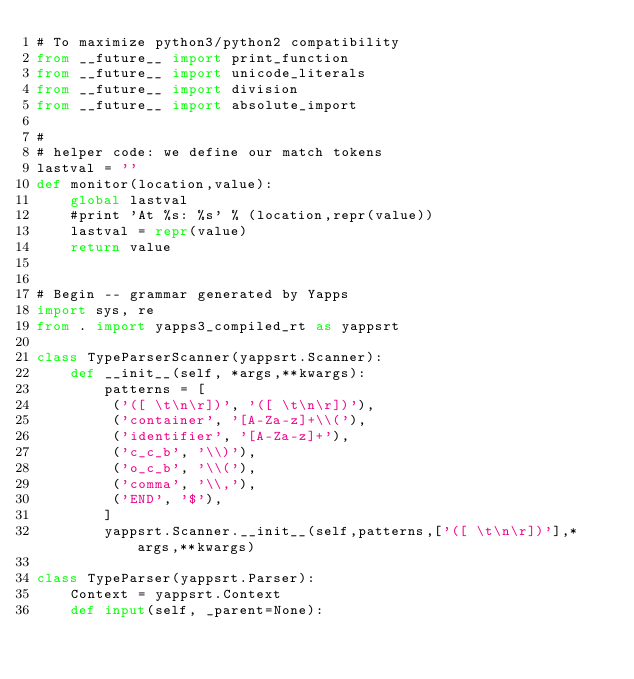Convert code to text. <code><loc_0><loc_0><loc_500><loc_500><_Python_># To maximize python3/python2 compatibility
from __future__ import print_function
from __future__ import unicode_literals
from __future__ import division
from __future__ import absolute_import

#
# helper code: we define our match tokens
lastval = ''
def monitor(location,value):
    global lastval
    #print 'At %s: %s' % (location,repr(value))
    lastval = repr(value)
    return value


# Begin -- grammar generated by Yapps
import sys, re
from . import yapps3_compiled_rt as yappsrt

class TypeParserScanner(yappsrt.Scanner):
    def __init__(self, *args,**kwargs):
        patterns = [
         ('([ \t\n\r])', '([ \t\n\r])'),
         ('container', '[A-Za-z]+\\('),
         ('identifier', '[A-Za-z]+'),
         ('c_c_b', '\\)'),
         ('o_c_b', '\\('),
         ('comma', '\\,'),
         ('END', '$'),
        ]
        yappsrt.Scanner.__init__(self,patterns,['([ \t\n\r])'],*args,**kwargs)

class TypeParser(yappsrt.Parser):
    Context = yappsrt.Context
    def input(self, _parent=None):</code> 